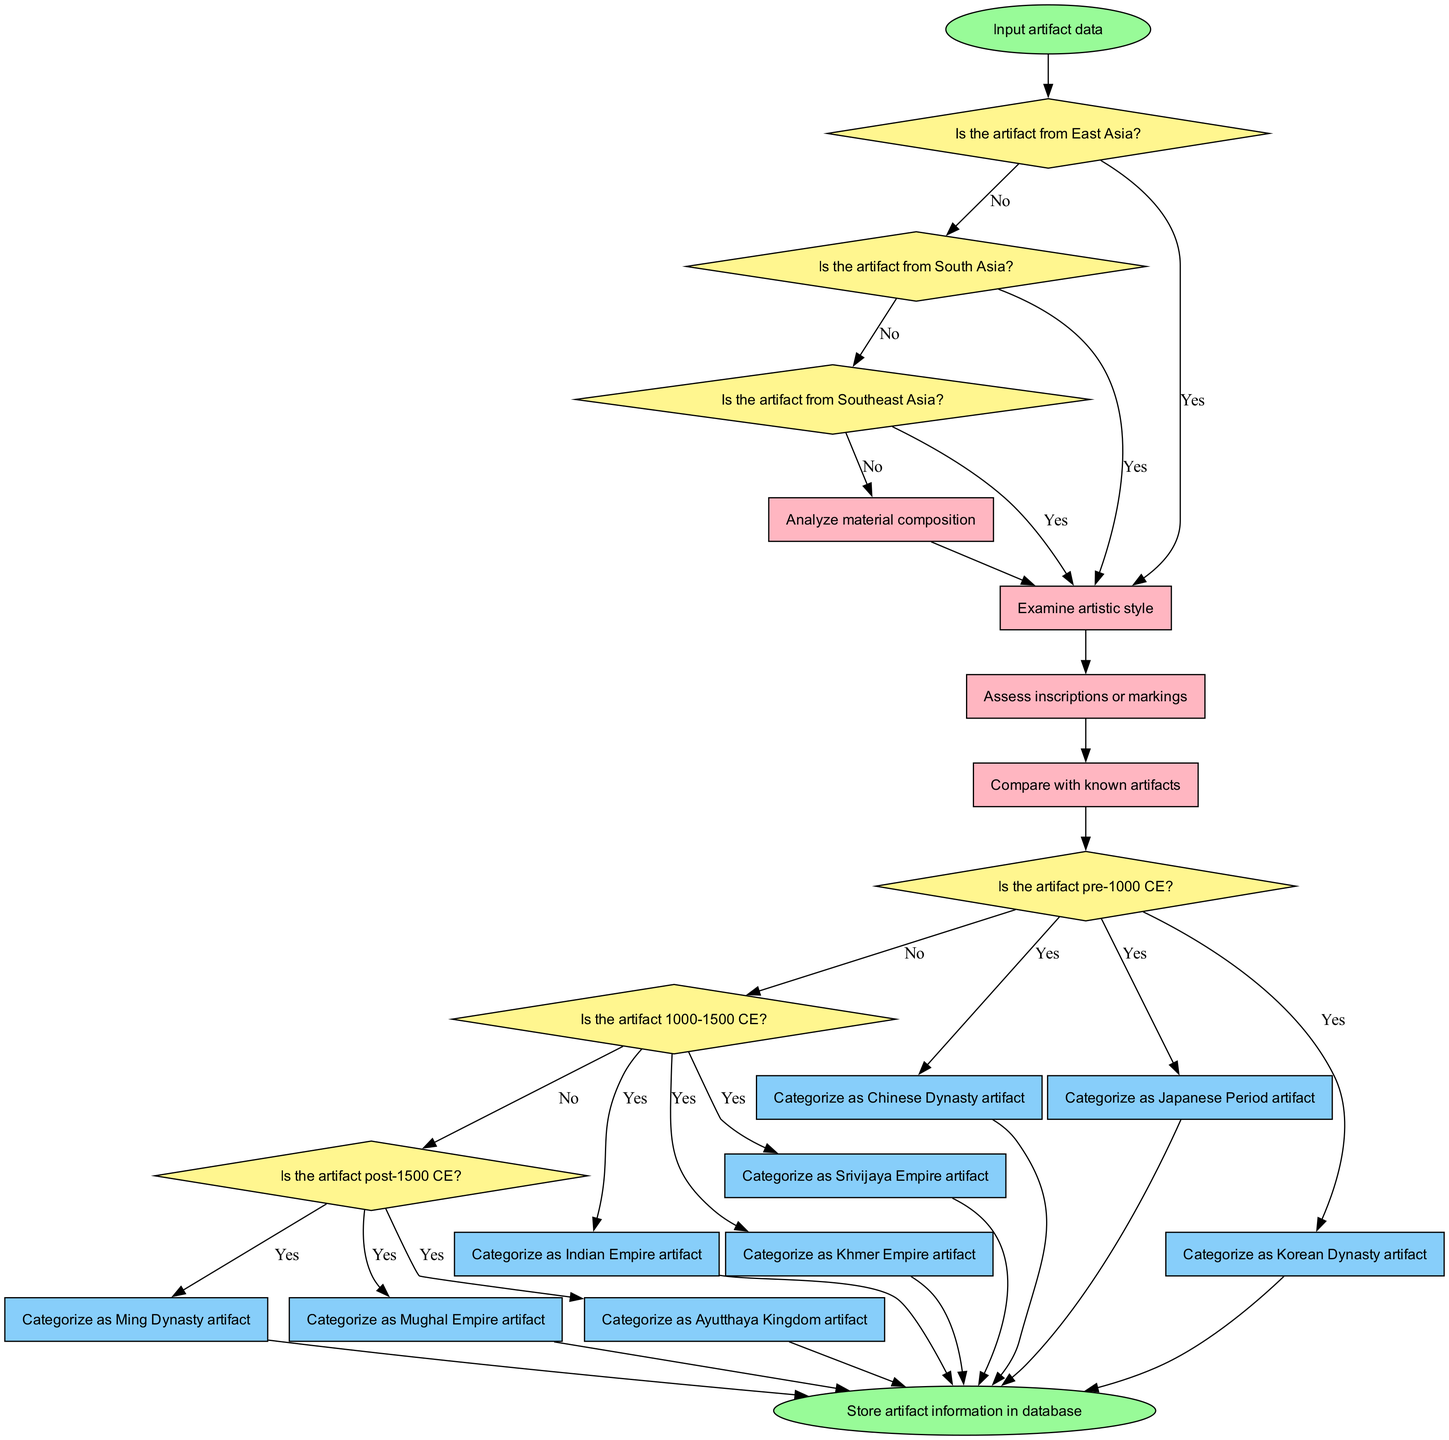What's the first step in the flowchart? The flowchart begins with the "Input artifact data" node, which is indicated as the starting point of the diagram.
Answer: Input artifact data How many decision nodes are there in the flowchart? The flowchart has six decision nodes that evaluate whether the artifact belongs to different regions or time periods.
Answer: Six What process is assessed after determining if the artifact is from East or South Asia? After determining the region, the flowchart proceeds to the process of "Examine artistic style," which assesses characteristics of the artifact in terms of artistic expression.
Answer: Examine artistic style What artifact would you categorize if it is from Southeast Asia and pre-1000 CE? Following the flowchart’s logic, an artifact from Southeast Asia that is pre-1000 CE leads to categorizing it as a "Khmer Empire artifact."
Answer: Khmer Empire artifact Which output corresponds to an artifact that is post-1500 CE? The outputs relevant to artifacts that fall within the post-1500 CE timeline include "Ming Dynasty artifact," "Mughal Empire artifact," and "Ayutthaya Kingdom artifact."
Answer: Ming Dynasty artifact, Mughal Empire artifact, Ayutthaya Kingdom artifact What node leads to the final step of storing information? The flowchart connects all output nodes to the final step, which is "Store artifact information in database," indicating that all categorized artifacts will lead to this endpoint.
Answer: Store artifact information in database What is the last process before checking the era of the artifact? The last process before checking the era is "Assess inscriptions or markings," which evaluates any written data present on the artifact prior to categorization based on historical periods.
Answer: Assess inscriptions or markings Which decision node comes after assessing inscriptions or markings? After assessing inscriptions or markings, the next decision node is "Is the artifact pre-1000 CE?" which continues the classification by evaluating the era of the artifact.
Answer: Is the artifact pre-1000 CE? How many output nodes are defined in the flowchart? The flowchart has nine output nodes representing the different categories into which the artifacts can be classified based on their characteristics and historical context.
Answer: Nine 